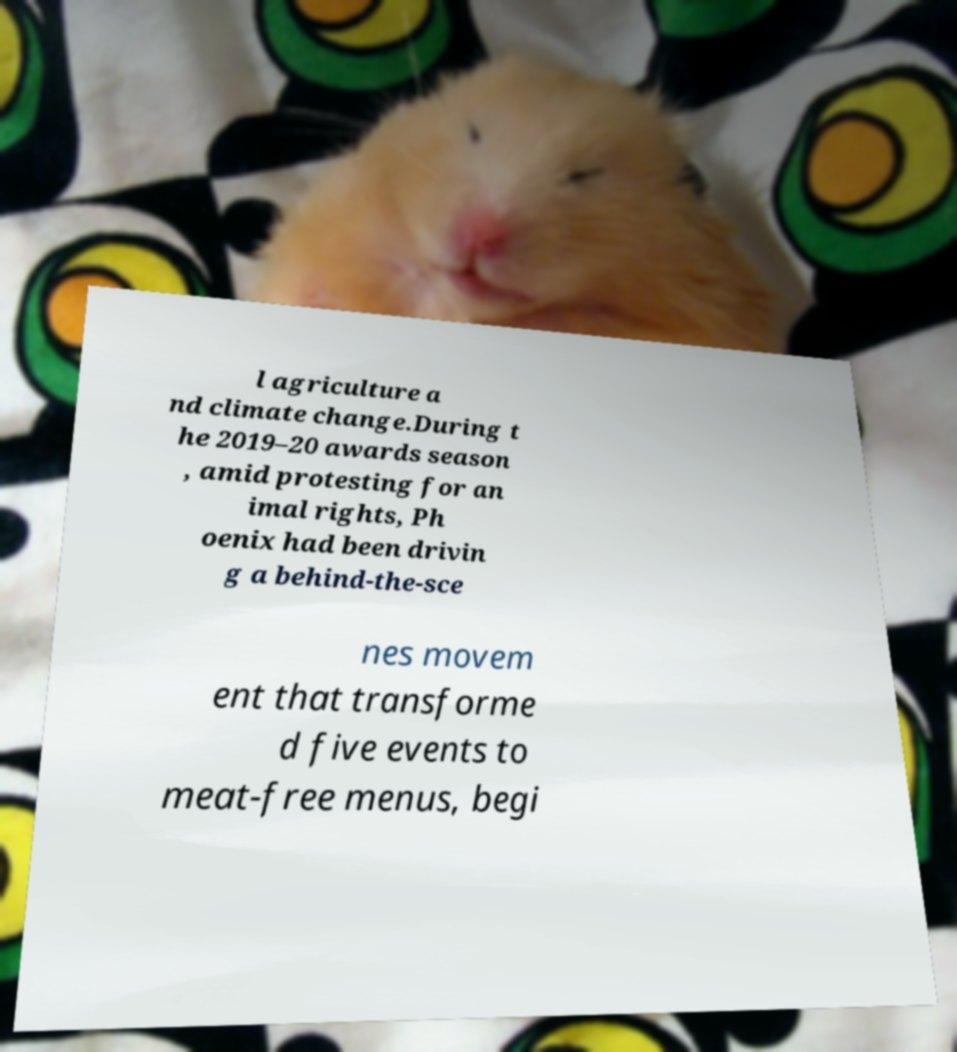There's text embedded in this image that I need extracted. Can you transcribe it verbatim? l agriculture a nd climate change.During t he 2019–20 awards season , amid protesting for an imal rights, Ph oenix had been drivin g a behind-the-sce nes movem ent that transforme d five events to meat-free menus, begi 